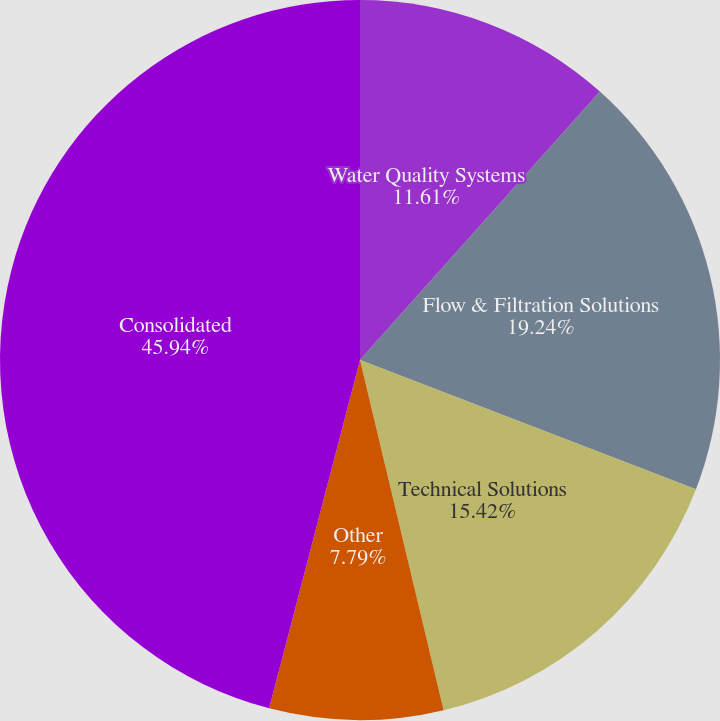Convert chart to OTSL. <chart><loc_0><loc_0><loc_500><loc_500><pie_chart><fcel>Water Quality Systems<fcel>Flow & Filtration Solutions<fcel>Technical Solutions<fcel>Other<fcel>Consolidated<nl><fcel>11.61%<fcel>19.24%<fcel>15.42%<fcel>7.79%<fcel>45.94%<nl></chart> 